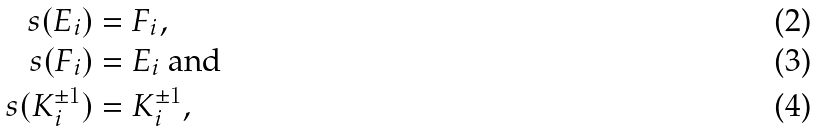Convert formula to latex. <formula><loc_0><loc_0><loc_500><loc_500>\ s ( E _ { i } ) & = F _ { i } , \\ \ s ( F _ { i } ) & = E _ { i } \text { and} \\ \ s ( K _ { i } ^ { \pm 1 } ) & = K _ { i } ^ { \pm 1 } ,</formula> 